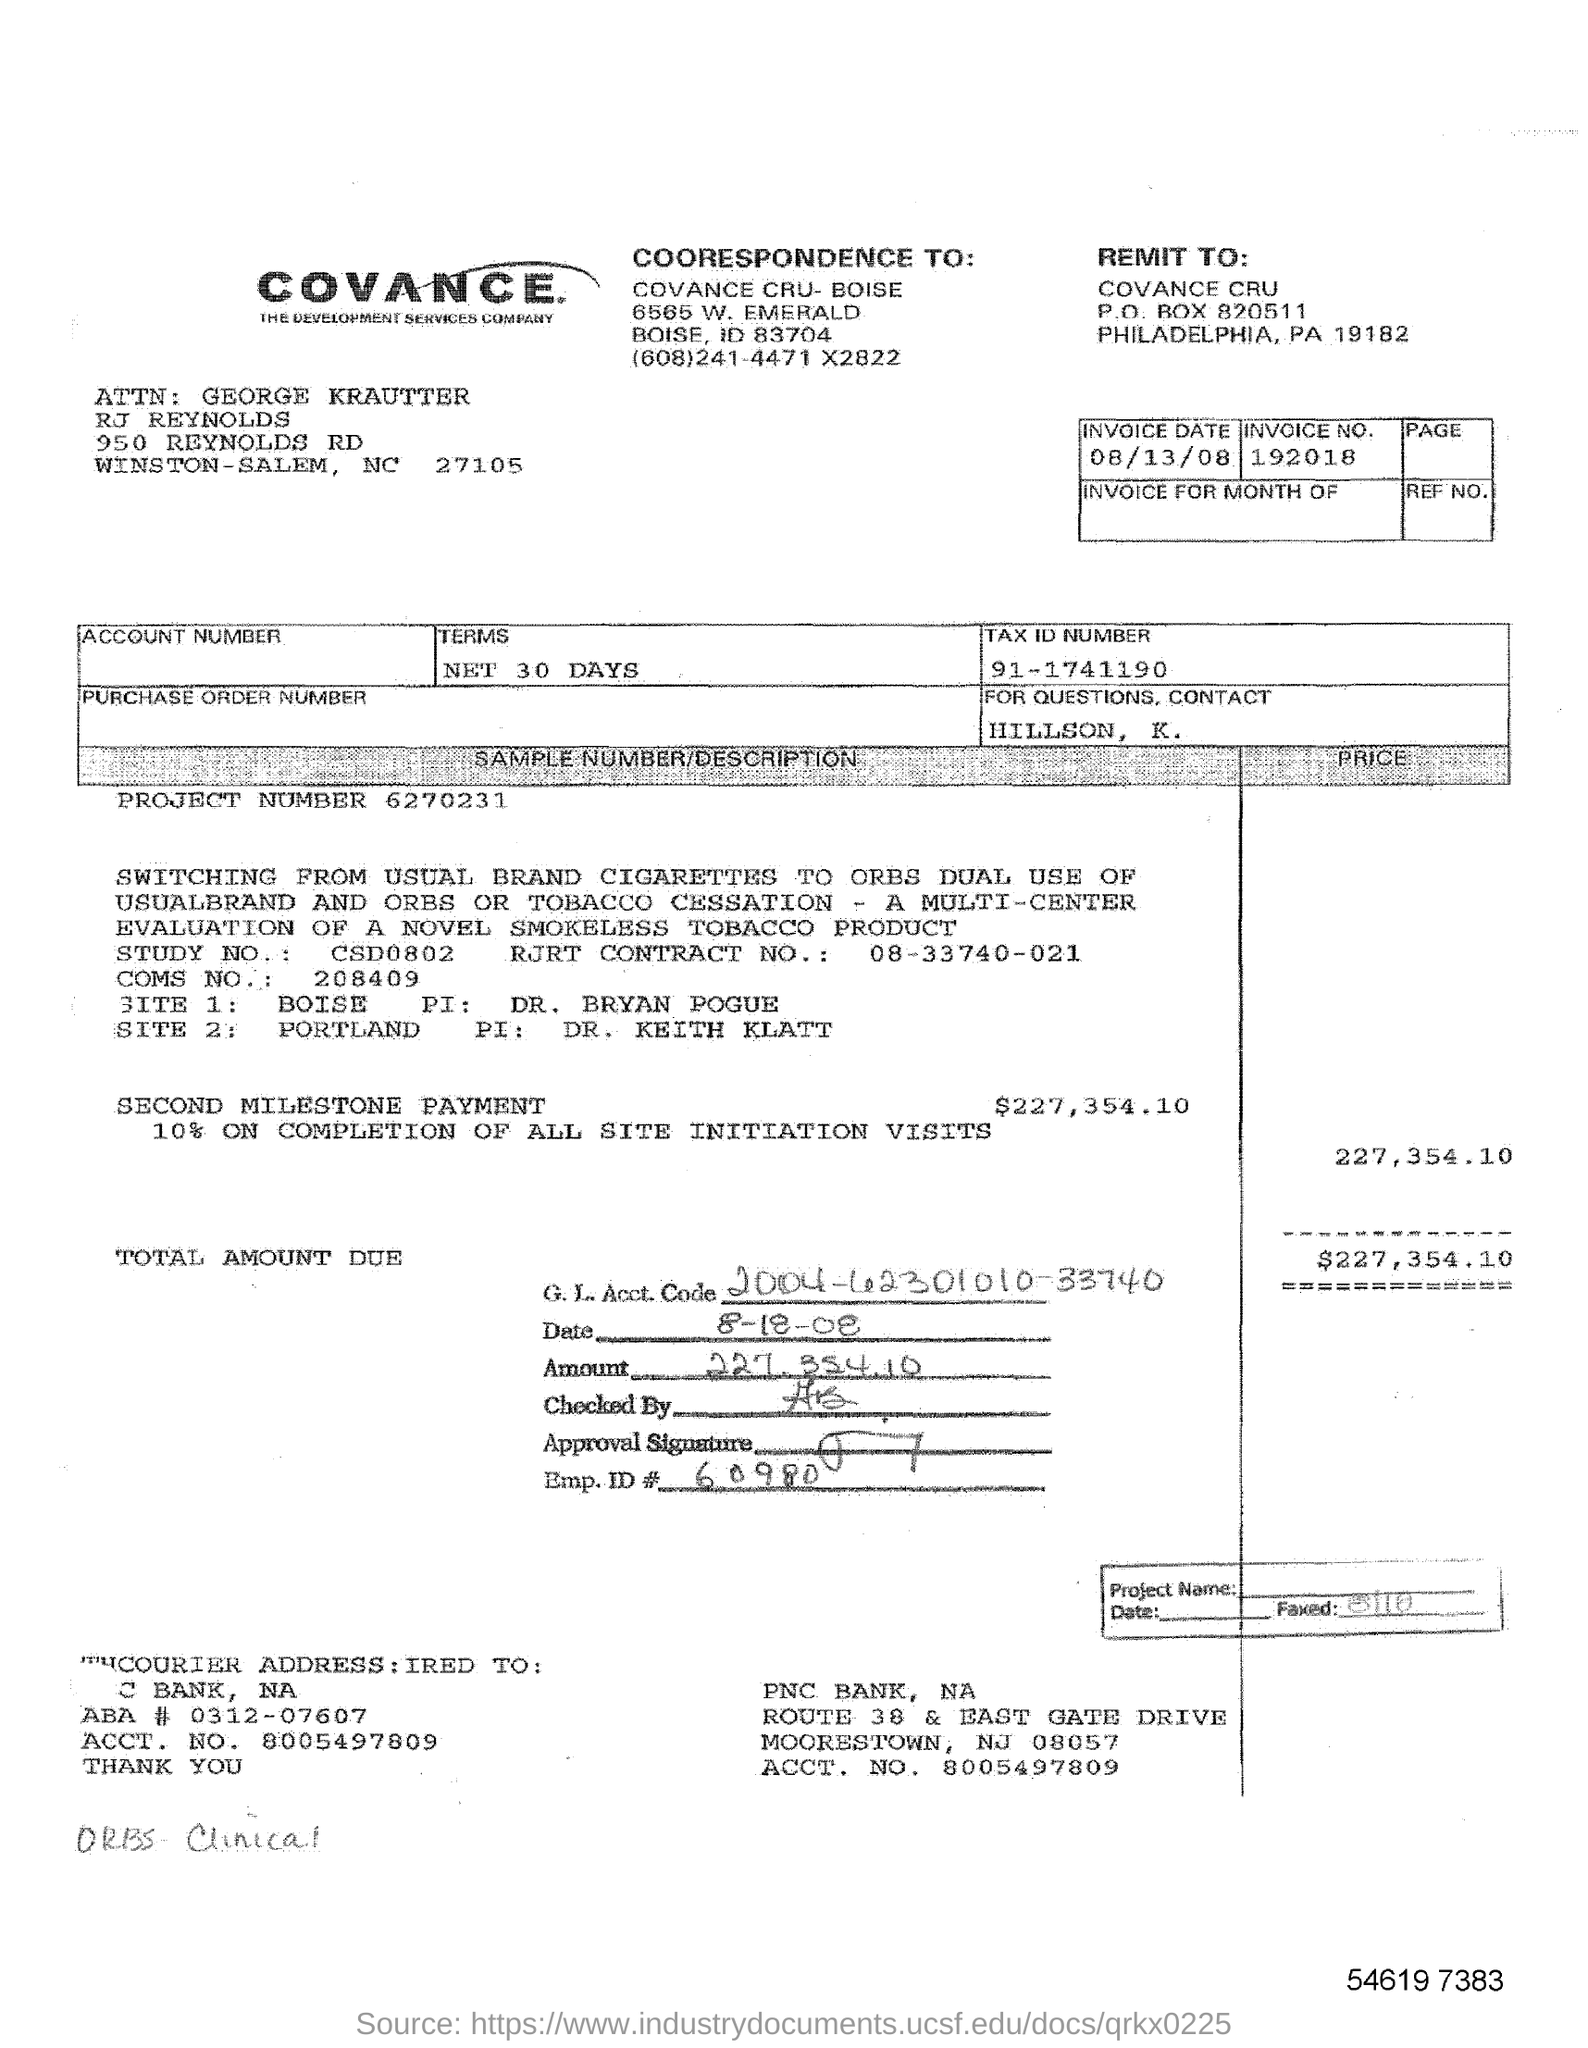Identify some key points in this picture. The invoice date is August 13, 2008. The INVOICE NO. is 192018. The INVOICE NO is 192018. I'm sorry, but I need more context to accurately understand what you are asking for. Could you please provide more information or clarify your question? A tax identification number is a unique number assigned to businesses and individuals by the government for the purpose of identifying and tracking their tax liability. The specific tax identification number you provided, 91-1741190, belongs to a business entity in India. 